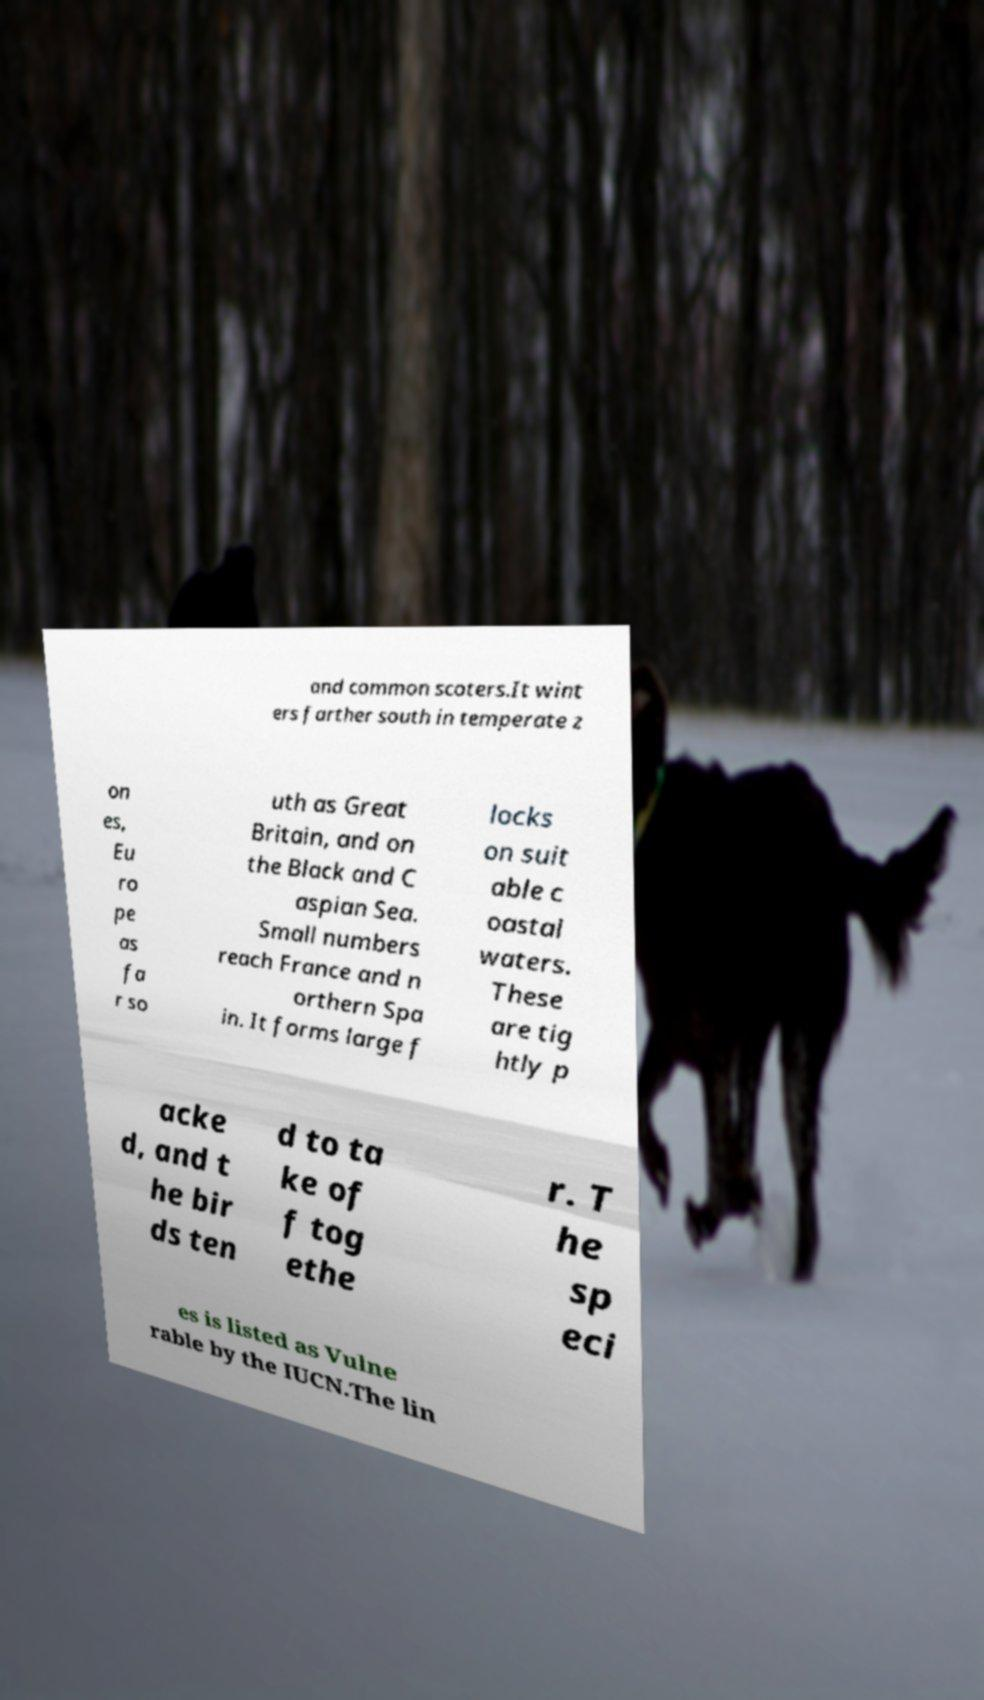What messages or text are displayed in this image? I need them in a readable, typed format. and common scoters.It wint ers farther south in temperate z on es, Eu ro pe as fa r so uth as Great Britain, and on the Black and C aspian Sea. Small numbers reach France and n orthern Spa in. It forms large f locks on suit able c oastal waters. These are tig htly p acke d, and t he bir ds ten d to ta ke of f tog ethe r. T he sp eci es is listed as Vulne rable by the IUCN.The lin 